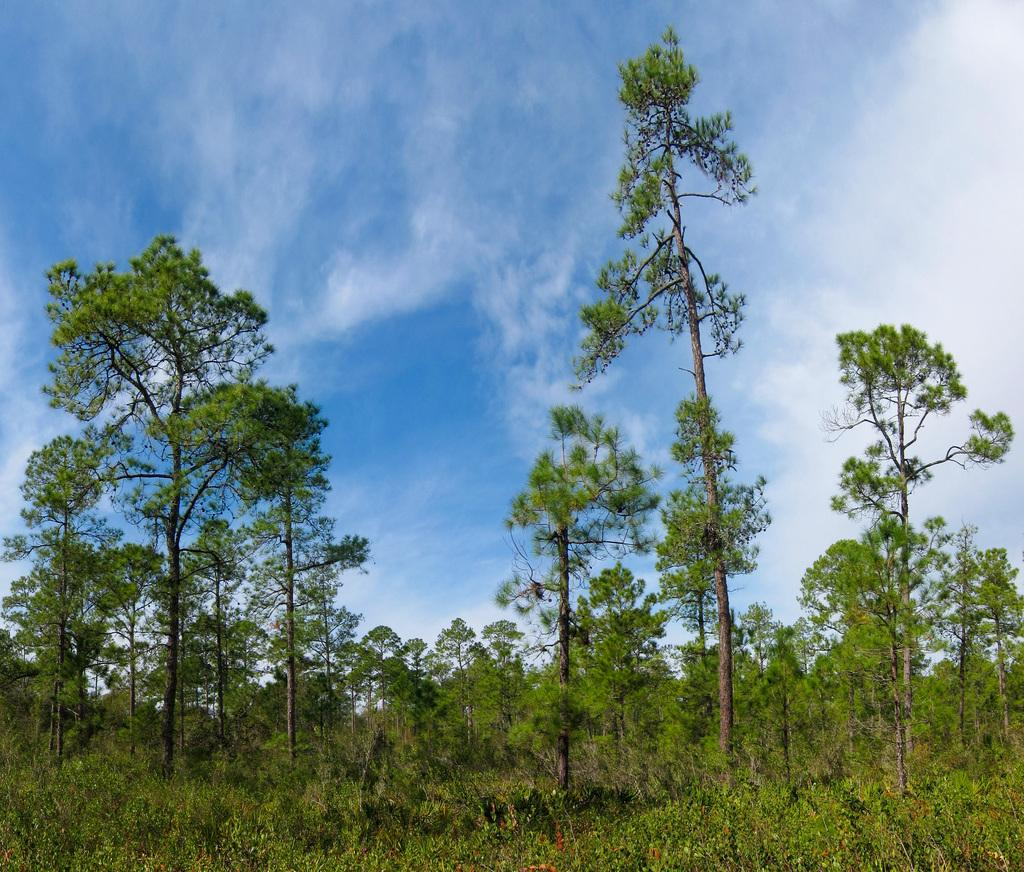What type of vegetation can be seen in the image? There are plants and trees in the image. Can you describe the background of the image? The sky is visible behind the trees in the image. Where is the library located in the image? There is no library present in the image. 